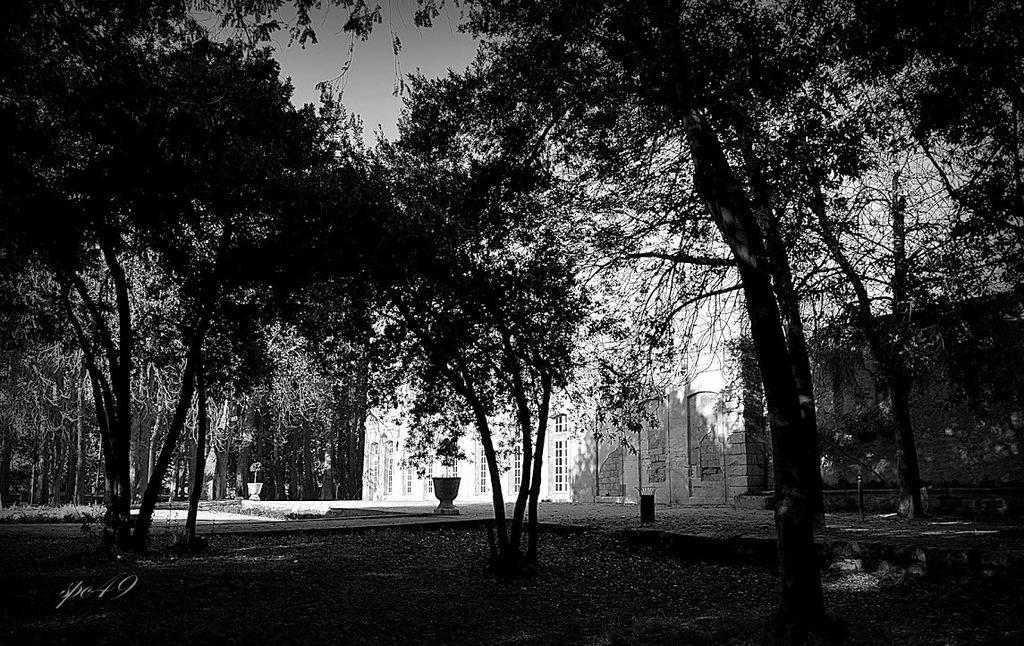What type of vegetation can be seen in the image? There are trees in the image. What structure is visible in the background of the image? There is a building in the background of the image. What part of the natural environment is visible in the image? The sky is visible in the background of the image. How many lizards are climbing on the trees in the image? There are no lizards present in the image; it only features trees and a building in the background. Can you tell me where the entrance to the cellar is located in the image? There is no mention of a cellar in the image, so its location cannot be determined. 